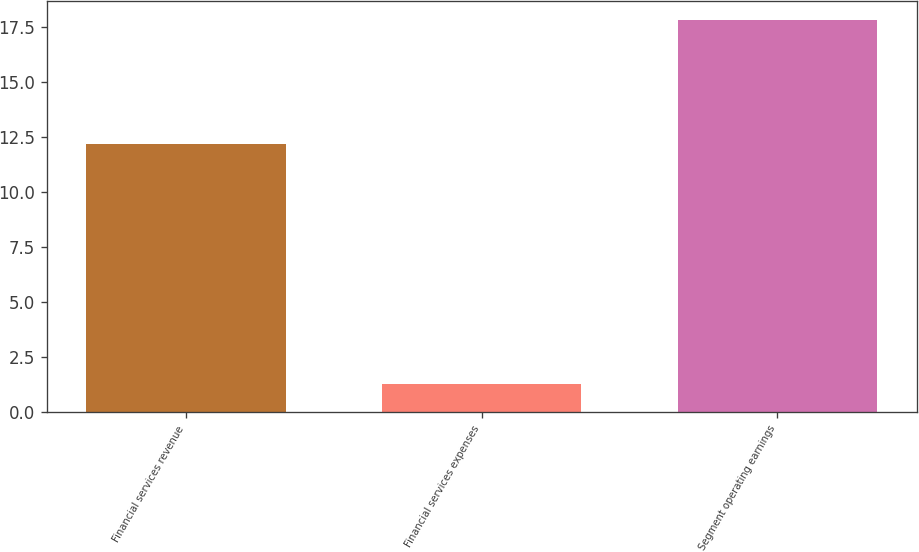Convert chart. <chart><loc_0><loc_0><loc_500><loc_500><bar_chart><fcel>Financial services revenue<fcel>Financial services expenses<fcel>Segment operating earnings<nl><fcel>12.2<fcel>1.3<fcel>17.8<nl></chart> 